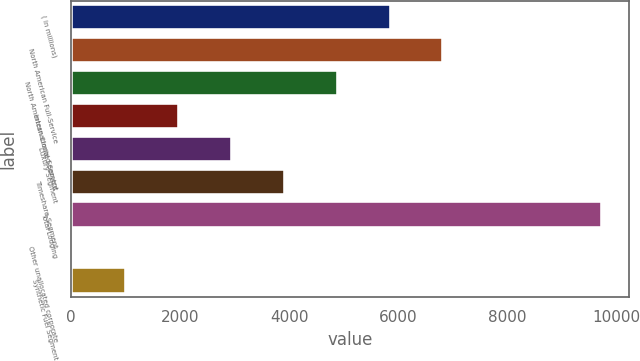Convert chart to OTSL. <chart><loc_0><loc_0><loc_500><loc_500><bar_chart><fcel>( in millions)<fcel>North American Full-Service<fcel>North American Limited-Service<fcel>International Segment<fcel>Luxury Segment<fcel>Timeshare Segment<fcel>Total Lodging<fcel>Other unallocated corporate<fcel>Synthetic Fuel Segment<nl><fcel>5857.8<fcel>6826.6<fcel>4889<fcel>1982.6<fcel>2951.4<fcel>3920.2<fcel>9733<fcel>45<fcel>1013.8<nl></chart> 